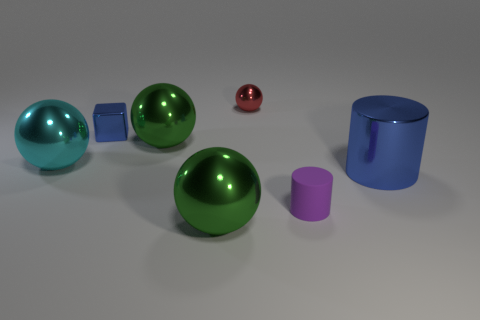There is a large metallic object behind the large cyan metallic ball; is its color the same as the shiny thing in front of the large cylinder?
Ensure brevity in your answer.  Yes. What number of shiny balls are in front of the red sphere?
Make the answer very short. 3. How many big metallic things have the same color as the small metallic cube?
Ensure brevity in your answer.  1. Is the material of the small object on the left side of the red ball the same as the small red object?
Give a very brief answer. Yes. What number of red balls are the same material as the big cylinder?
Keep it short and to the point. 1. Are there more blue things behind the big cyan metallic object than tiny blue rubber cubes?
Ensure brevity in your answer.  Yes. The shiny object that is the same color as the big cylinder is what size?
Make the answer very short. Small. Are there any gray rubber things that have the same shape as the tiny purple rubber thing?
Your response must be concise. No. What number of objects are small metallic things or large metal things?
Offer a very short reply. 6. There is a green metallic thing in front of the blue thing in front of the cyan shiny sphere; what number of big objects are right of it?
Offer a terse response. 1. 